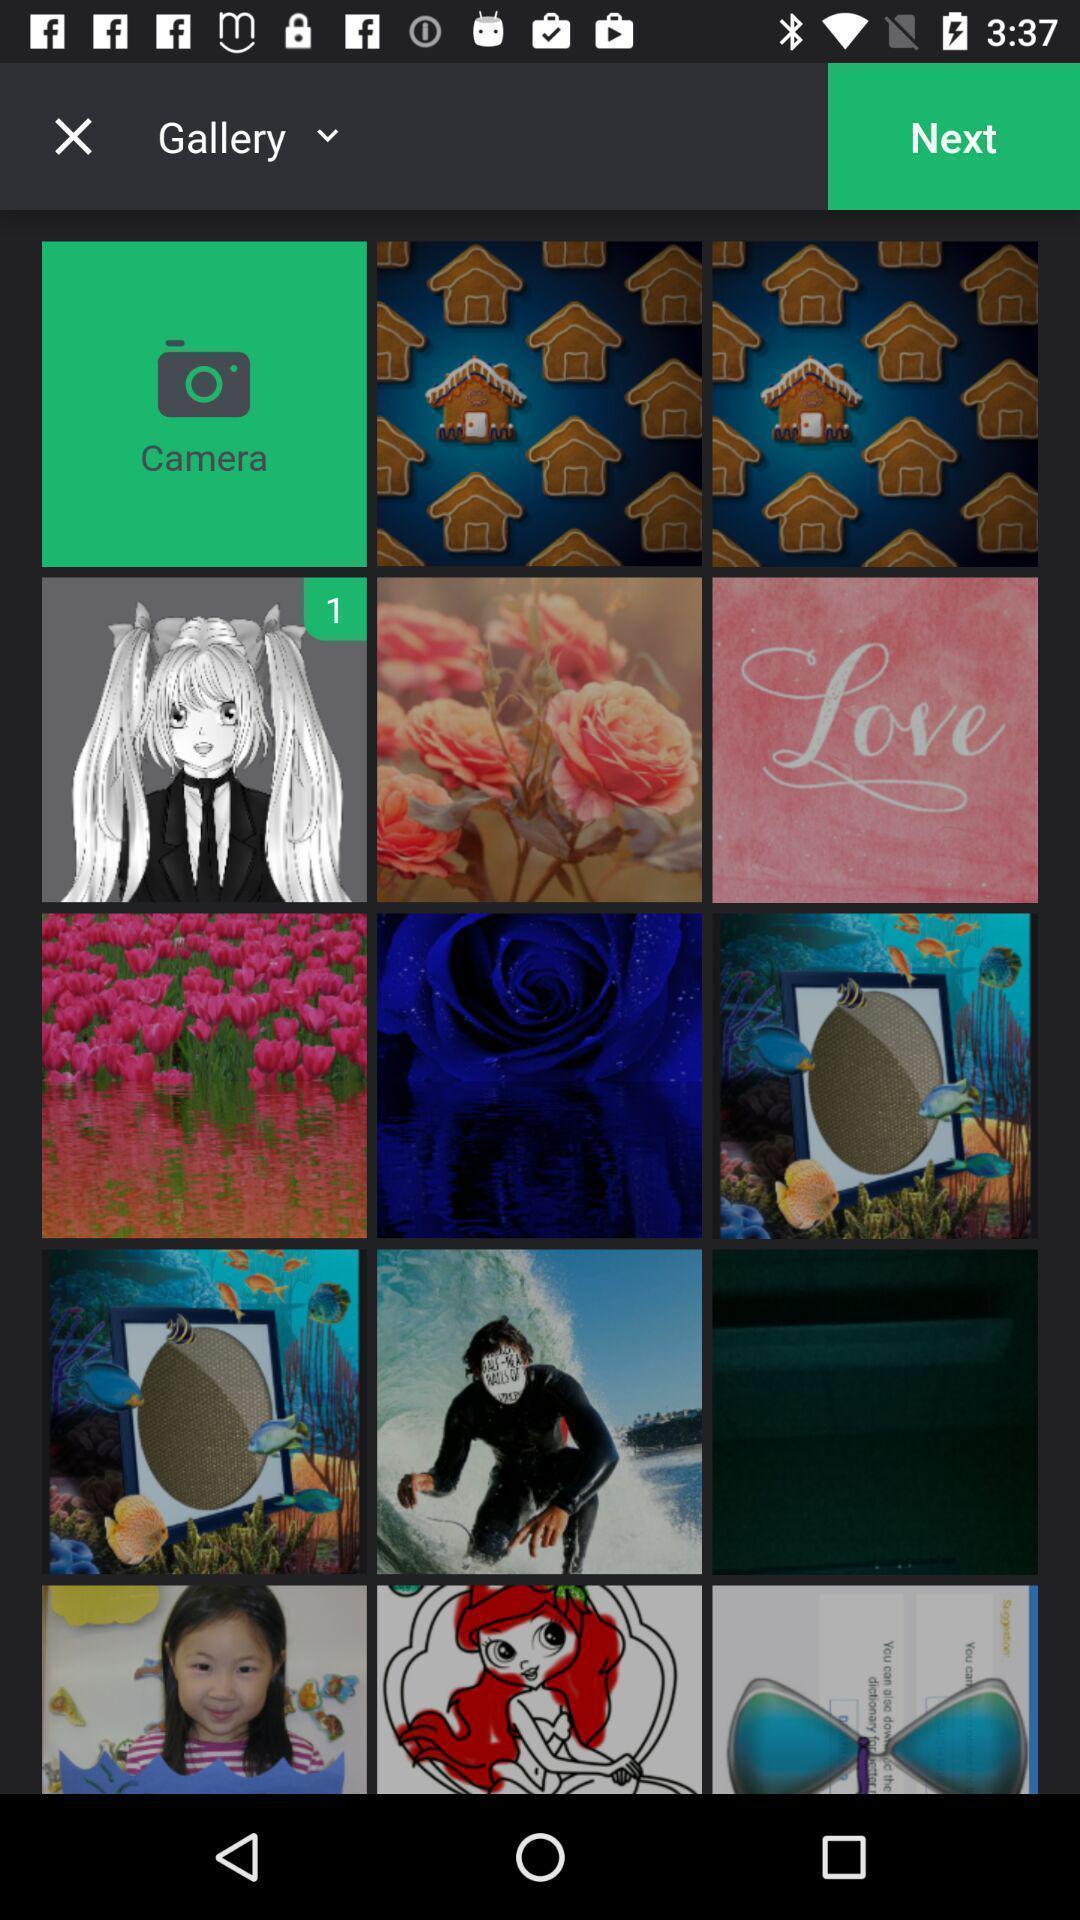Describe the visual elements of this screenshot. Screen shows multiple images. 